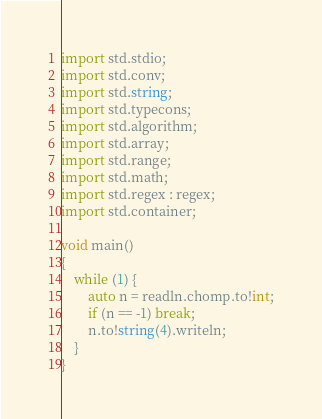<code> <loc_0><loc_0><loc_500><loc_500><_D_>import std.stdio;
import std.conv;
import std.string;
import std.typecons;
import std.algorithm;
import std.array;
import std.range;
import std.math;
import std.regex : regex;
import std.container;

void main()
{
	while (1) {
		auto n = readln.chomp.to!int;
		if (n == -1) break;
		n.to!string(4).writeln;
	}
}</code> 